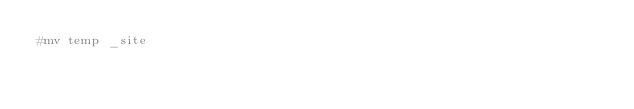Convert code to text. <code><loc_0><loc_0><loc_500><loc_500><_Bash_>#mv temp _site
</code> 